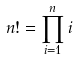Convert formula to latex. <formula><loc_0><loc_0><loc_500><loc_500>n ! = \prod _ { i = 1 } ^ { n } i</formula> 